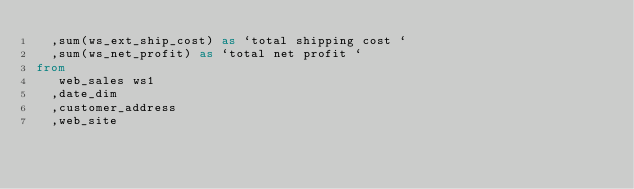<code> <loc_0><loc_0><loc_500><loc_500><_SQL_>  ,sum(ws_ext_ship_cost) as `total shipping cost `
  ,sum(ws_net_profit) as `total net profit `
from
   web_sales ws1
  ,date_dim
  ,customer_address
  ,web_site</code> 